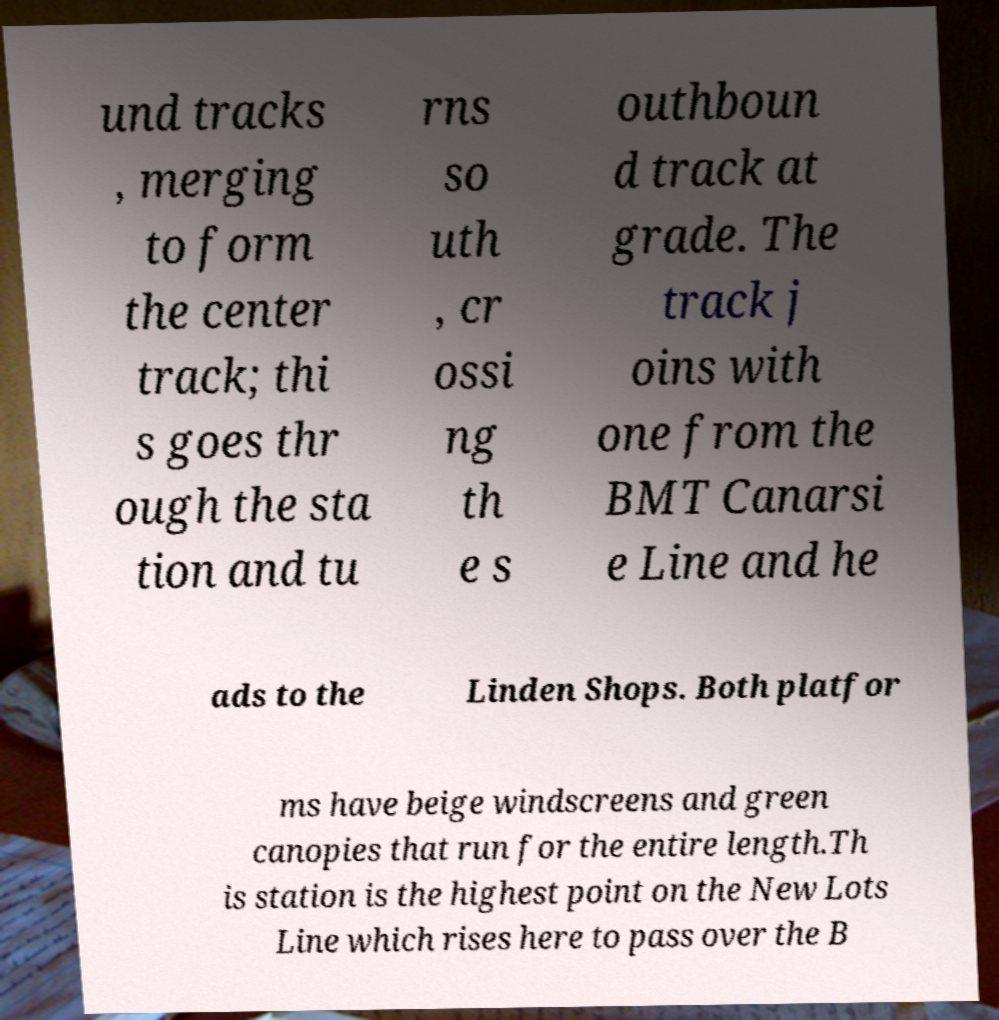There's text embedded in this image that I need extracted. Can you transcribe it verbatim? und tracks , merging to form the center track; thi s goes thr ough the sta tion and tu rns so uth , cr ossi ng th e s outhboun d track at grade. The track j oins with one from the BMT Canarsi e Line and he ads to the Linden Shops. Both platfor ms have beige windscreens and green canopies that run for the entire length.Th is station is the highest point on the New Lots Line which rises here to pass over the B 